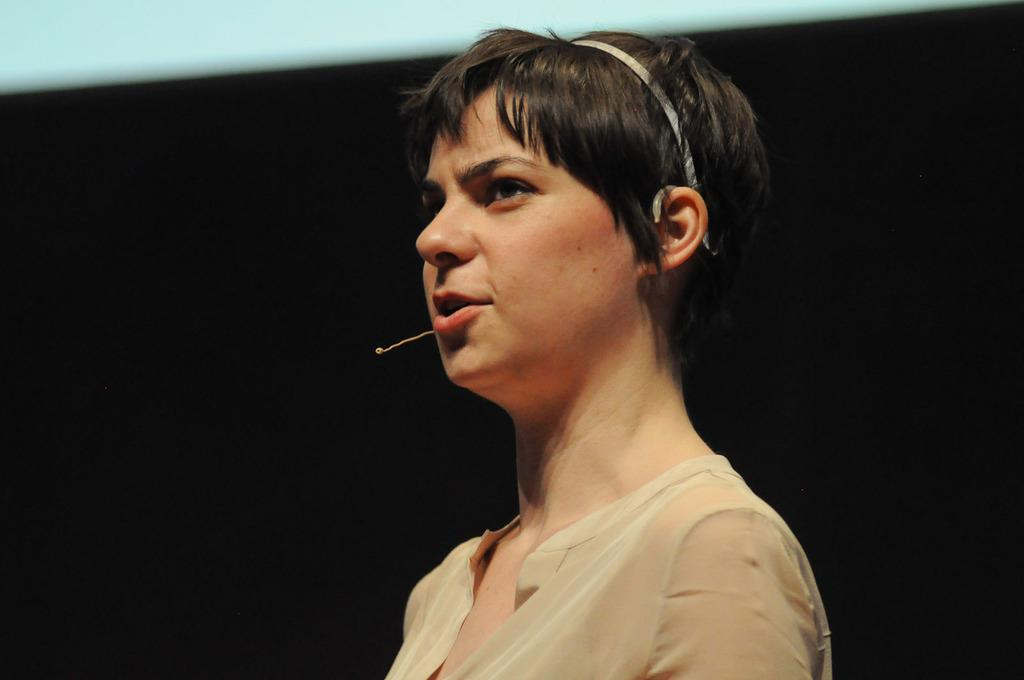Who is the main subject in the image? There is a lady in the image. Where is the lady located in the image? The lady is at the center of the image. What is the lady doing in the image? The lady is talking. What object is in front of the lady? There is a microphone in front of the lady. What can be observed about the background of the image? The background of the image is dark. What type of stick is the lady using to force her beliefs on the audience in the image? There is no stick or forceful action present in the image. The lady is simply talking with a microphone in front of her. 